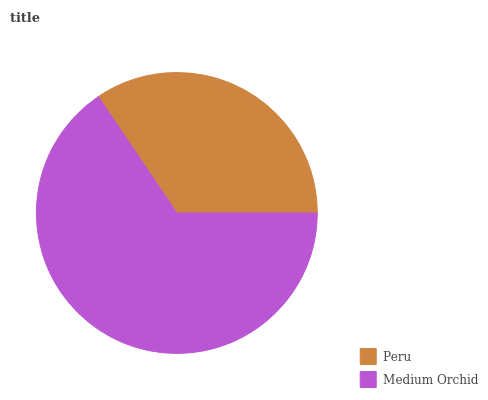Is Peru the minimum?
Answer yes or no. Yes. Is Medium Orchid the maximum?
Answer yes or no. Yes. Is Medium Orchid the minimum?
Answer yes or no. No. Is Medium Orchid greater than Peru?
Answer yes or no. Yes. Is Peru less than Medium Orchid?
Answer yes or no. Yes. Is Peru greater than Medium Orchid?
Answer yes or no. No. Is Medium Orchid less than Peru?
Answer yes or no. No. Is Medium Orchid the high median?
Answer yes or no. Yes. Is Peru the low median?
Answer yes or no. Yes. Is Peru the high median?
Answer yes or no. No. Is Medium Orchid the low median?
Answer yes or no. No. 